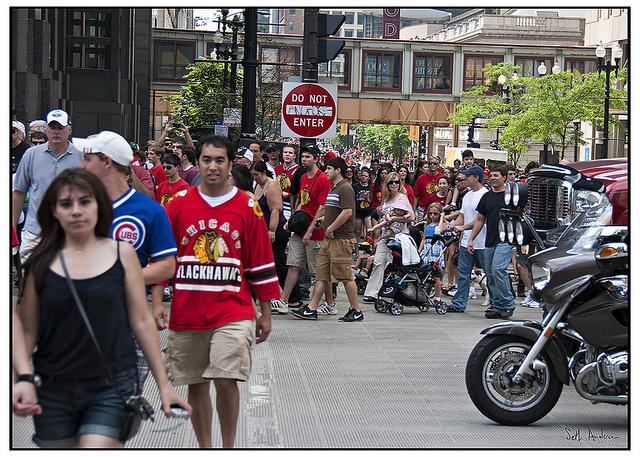Who captains the team of the jersey in red?

Choices:
A) mario iginla
B) jonathan toes
C) lionel messi
D) bill reid jonathan toes 